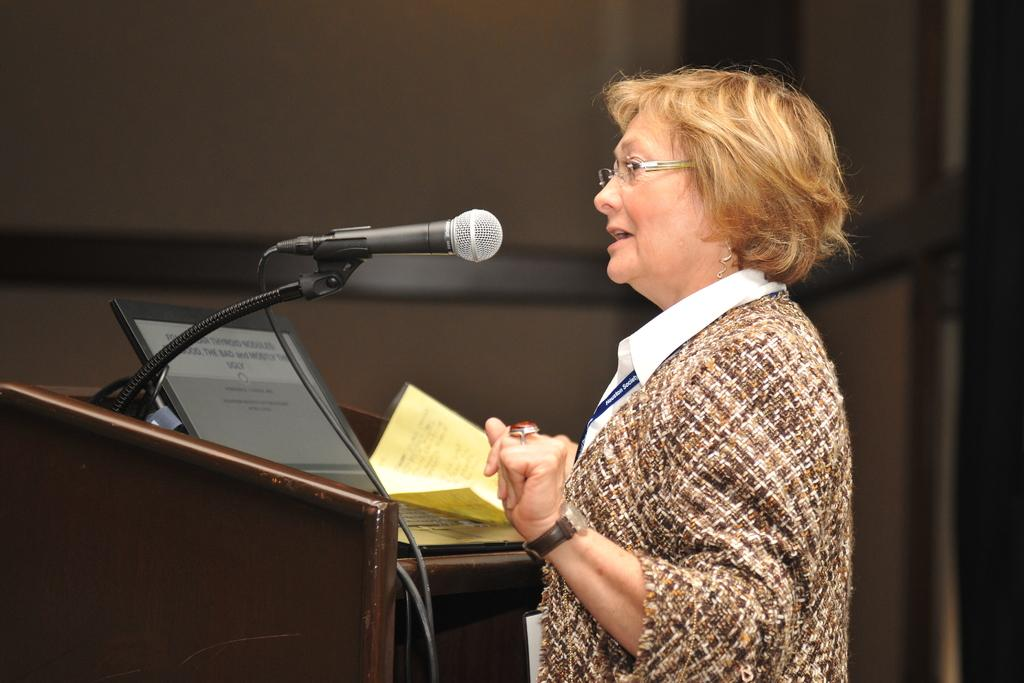Who is the main subject in the image? There is a woman in the image. What is the woman doing in the image? The woman is standing at a podium. What items can be seen on the podium? There are papers and a laptop on the podium. What device is attached to the podium for amplifying the woman's voice? There is a microphone attached to the podium. What type of shop can be seen in the background of the image? There is no shop visible in the image; it only shows a woman standing at a podium with papers, a laptop, and a microphone. 